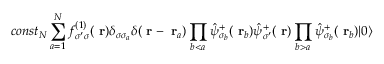<formula> <loc_0><loc_0><loc_500><loc_500>c o n s t _ { N } \sum _ { a = 1 } ^ { N } f _ { \sigma ^ { \prime } \sigma } ^ { ( 1 ) } ( r ) \delta _ { \sigma \sigma _ { a } } \delta ( r - r _ { a } ) \prod _ { b < a } \hat { \psi } _ { \sigma _ { b } } ^ { + } ( r _ { b } ) \hat { \psi } _ { \sigma ^ { \prime } } ^ { + } ( r ) \prod _ { b > a } \hat { \psi } _ { \sigma _ { b } } ^ { + } ( r _ { b } ) | 0 \rangle</formula> 